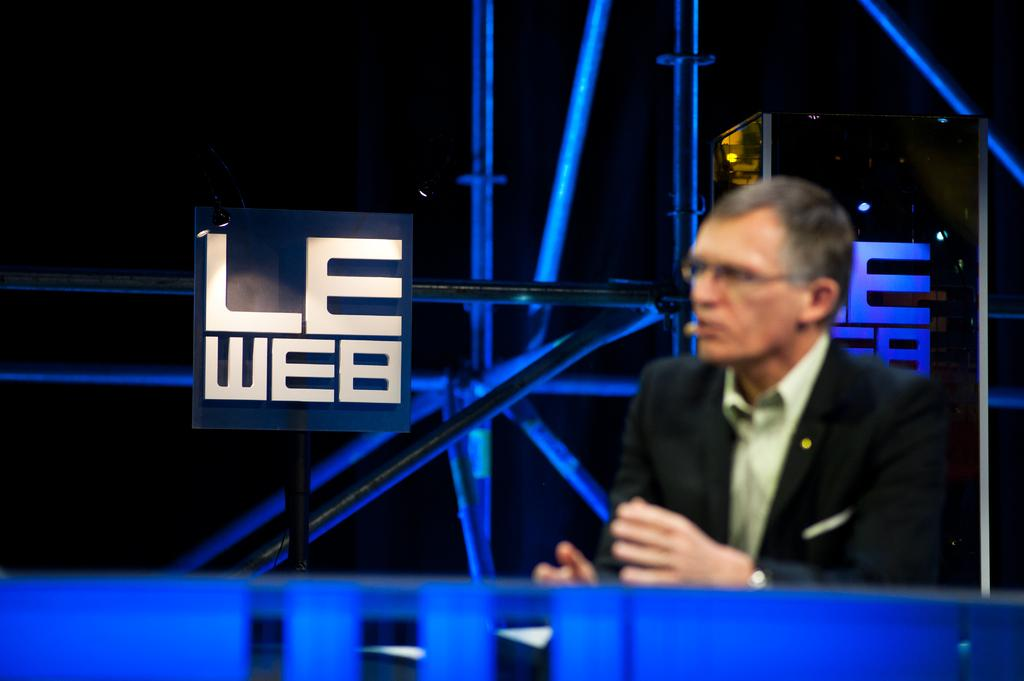Provide a one-sentence caption for the provided image. A man sits in front of a sign that says Le Web. 